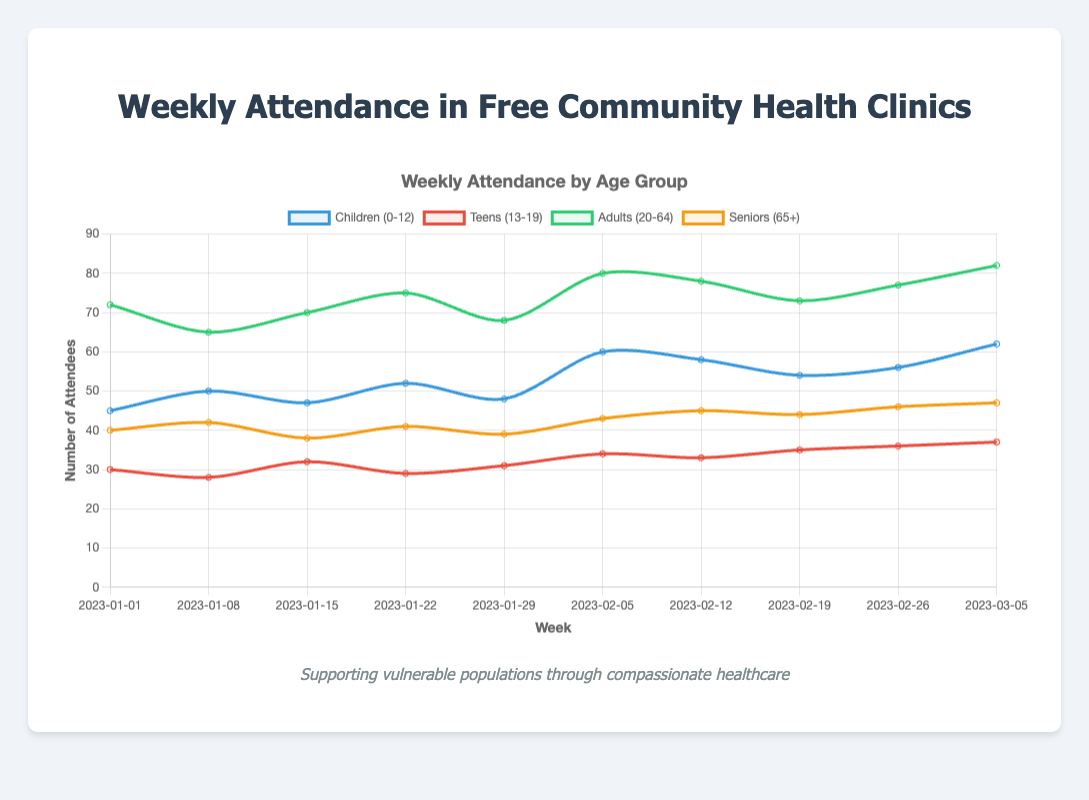What is the attendance trend for the Children (0-12) age group over the 10-week period? The line representing Children (0-12) in the chart shows upward movement from 45 to 62 over the 10-week period, indicating an increasing trend.
Answer: Increasing Which age group had the highest attendance in the week of 2023-01-22? In the week of 2023-01-22, the Adults (20-64) age group had the highest attendance with 75 attendees as shown by the peak on the corresponding line.
Answer: Adults (20-64) Compare the attendance between Teens (13-19) and Seniors (65+) in the first and last week. Which age group showed more growth? In the first week, Teens (13-19) had 30 attendees and Seniors (65+) had 40. In the last week, Teens (13-19) had 37, while Seniors (65+) had 47. Teens (13-19) grew by 7 (37-30) and Seniors (65+) grew by 7 (47-40). Both groups showed the same growth.
Answer: Same growth What is the average weekly attendance for the Adults (20-64) age group? The total attendance for Adults (20-64) over the 10 weeks is 72 + 65 + 70 + 75 + 68 + 80 + 78 + 73 + 77 + 82 = 740. The average is 740 / 10 = 74.
Answer: 74 Between which two consecutive weeks did the Children (0-12) age group see the largest increase in attendance? The largest increase for Children (0-12) can be found by calculating the differences between consecutive weeks. The increase from the week of 2023-01-29 (48) to 2023-02-05 (60) is 12, which is the largest.
Answer: 2023-01-29 to 2023-02-05 How did the attendance for Seniors (65+) change from the week of 2023-01-15 to 2023-01-22? The attendance for Seniors (65+) increased from 38 in the week of 2023-01-15 to 41 in the week of 2023-01-22, an increase of 3 attendees.
Answer: Increased by 3 Is there a week where all age groups show an increase in attendance compared to the previous week? Review each week-to-week change for all groups to see if they all increase. From the week of 2023-01-29 to 2023-02-05, all four age groups (Children (48 to 60), Teens (31 to 34), Adults (68 to 80), Seniors (39 to 43)) increased in attendance.
Answer: Week of 2023-02-05 Which color represents the Teens (13-19) age group on the chart? The chart uses red to represent the Teens (13-19) age group as indicated by the color of the corresponding line.
Answer: Red 